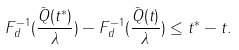Convert formula to latex. <formula><loc_0><loc_0><loc_500><loc_500>F _ { d } ^ { - 1 } ( \frac { \bar { Q } ( t ^ { * } ) } { \lambda } ) - F _ { d } ^ { - 1 } ( \frac { \bar { Q } ( t ) } { \lambda } ) \leq t ^ { * } - t .</formula> 